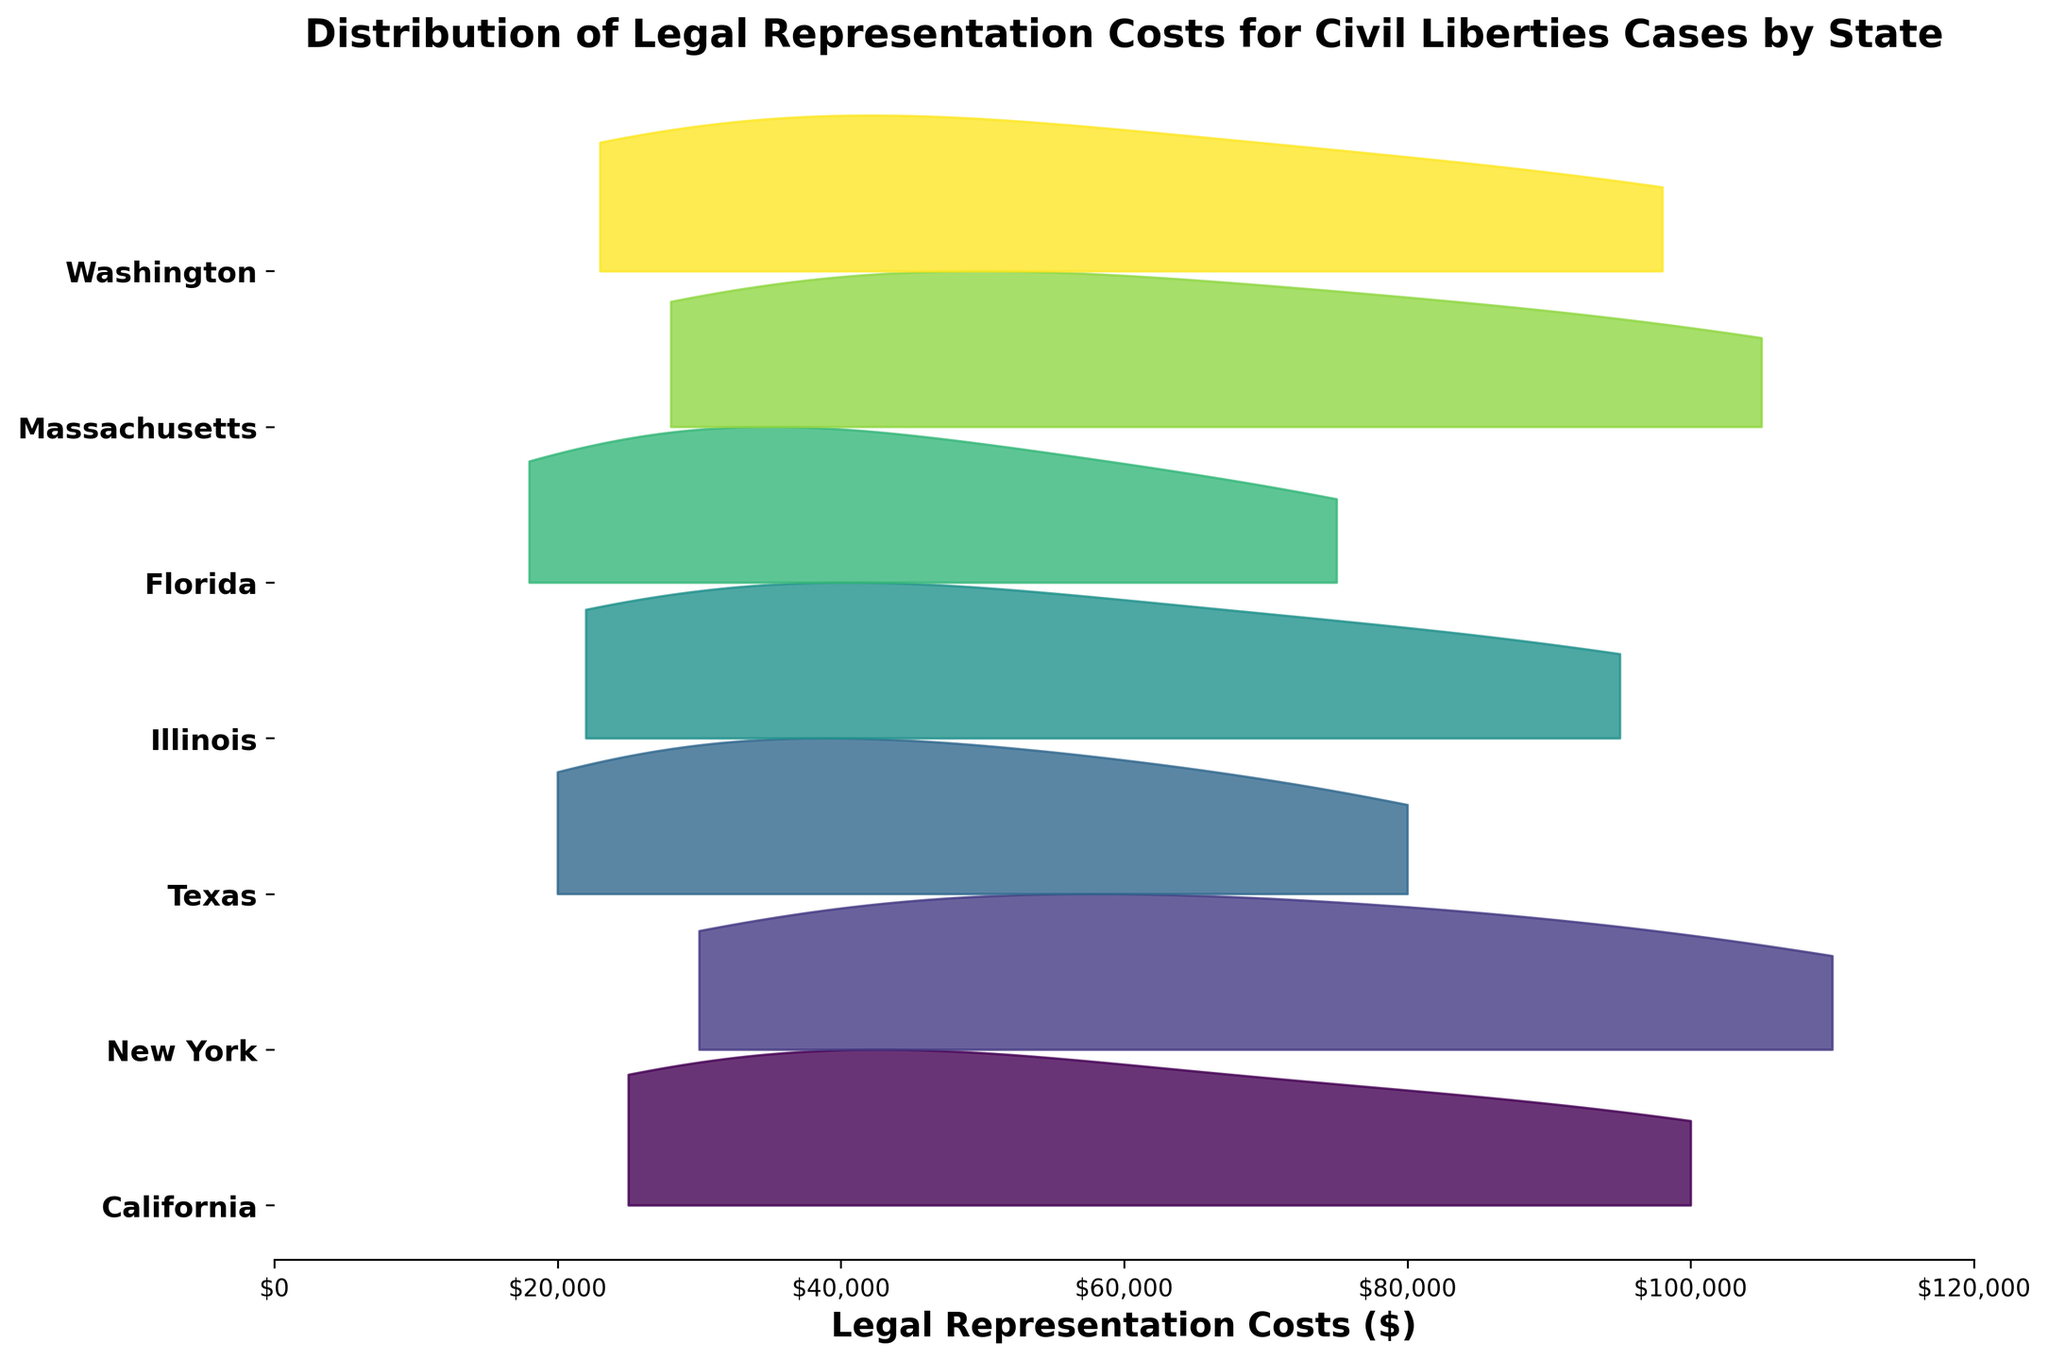What is the title of the plot? The title of the plot is located at the top and provides an overview of what the plot represents.
Answer: Distribution of Legal Representation Costs for Civil Liberties Cases by State Which state has the highest peak in legal representation costs? To determine which state has the highest peak, observe the vertical height of the peaks for each state's distribution.
Answer: New York In which state do the costs of legal representation appear to be the most widely spread? Look at the width of the distribution for each state. The most widely spread distribution will have the widest range on the x-axis.
Answer: California Between California and Texas, which state has a higher median legal representation cost? The median cost can be inferred by locating the central point of each state's distribution. California's distribution appears to be more centered around higher values compared to Texas.
Answer: California Which states have their distributions peaking at costs above $100,000? Identify the states whose peaks or significant portions of their distributions extend beyond the $100,000 mark on the x-axis.
Answer: California, New York, and Massachusetts Is the distribution of legal representation costs in Texas more or less variable than in Illinois? Compare the spread (width) of the distributions for Texas and Illinois. The more variable distribution will be wider.
Answer: Texas (less variable) Which state has the narrowest distribution of legal representation costs? The narrowest distribution will have the smallest spread on the x-axis, indicating less variability in cost.
Answer: Washington How do the peaks of legal representation costs for Florida and Massachusetts compare? Observe the vertical heights of the peaks for Florida and Massachusetts and compare which one is higher.
Answer: Massachusetts has a higher peak Do any states have a similar shape in their distribution of legal representation costs? Compare the shapes of the distributions. Look for states that have similar peaks and spreads.
Answer: California and New York have relatively similar shapes Which state's distribution extends the furthest on the x-axis, indicating the highest maximum legal representation cost observed? Look at the rightmost extent of each distribution to see which one reaches the furthest on the x-axis.
Answer: Massachusetts 